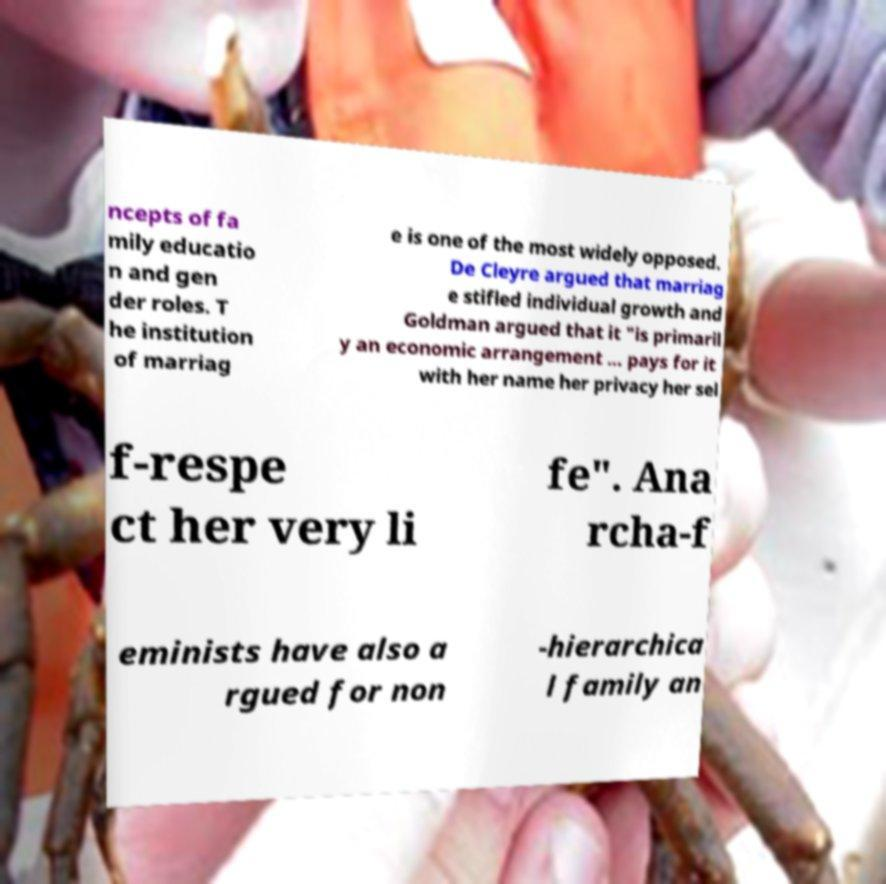Could you assist in decoding the text presented in this image and type it out clearly? ncepts of fa mily educatio n and gen der roles. T he institution of marriag e is one of the most widely opposed. De Cleyre argued that marriag e stifled individual growth and Goldman argued that it "is primaril y an economic arrangement ... pays for it with her name her privacy her sel f-respe ct her very li fe". Ana rcha-f eminists have also a rgued for non -hierarchica l family an 